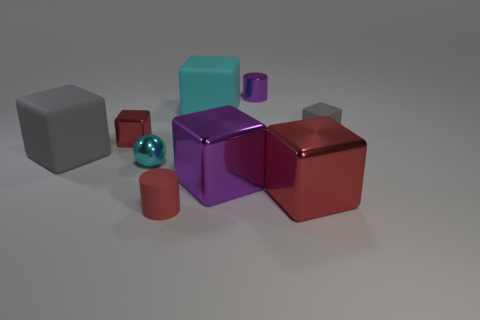Are there fewer big matte objects than big red shiny blocks? After observing the image, it appears that there are equal amounts of big matte objects and big red shiny blocks. Both types have two objects each in the visible scene. 